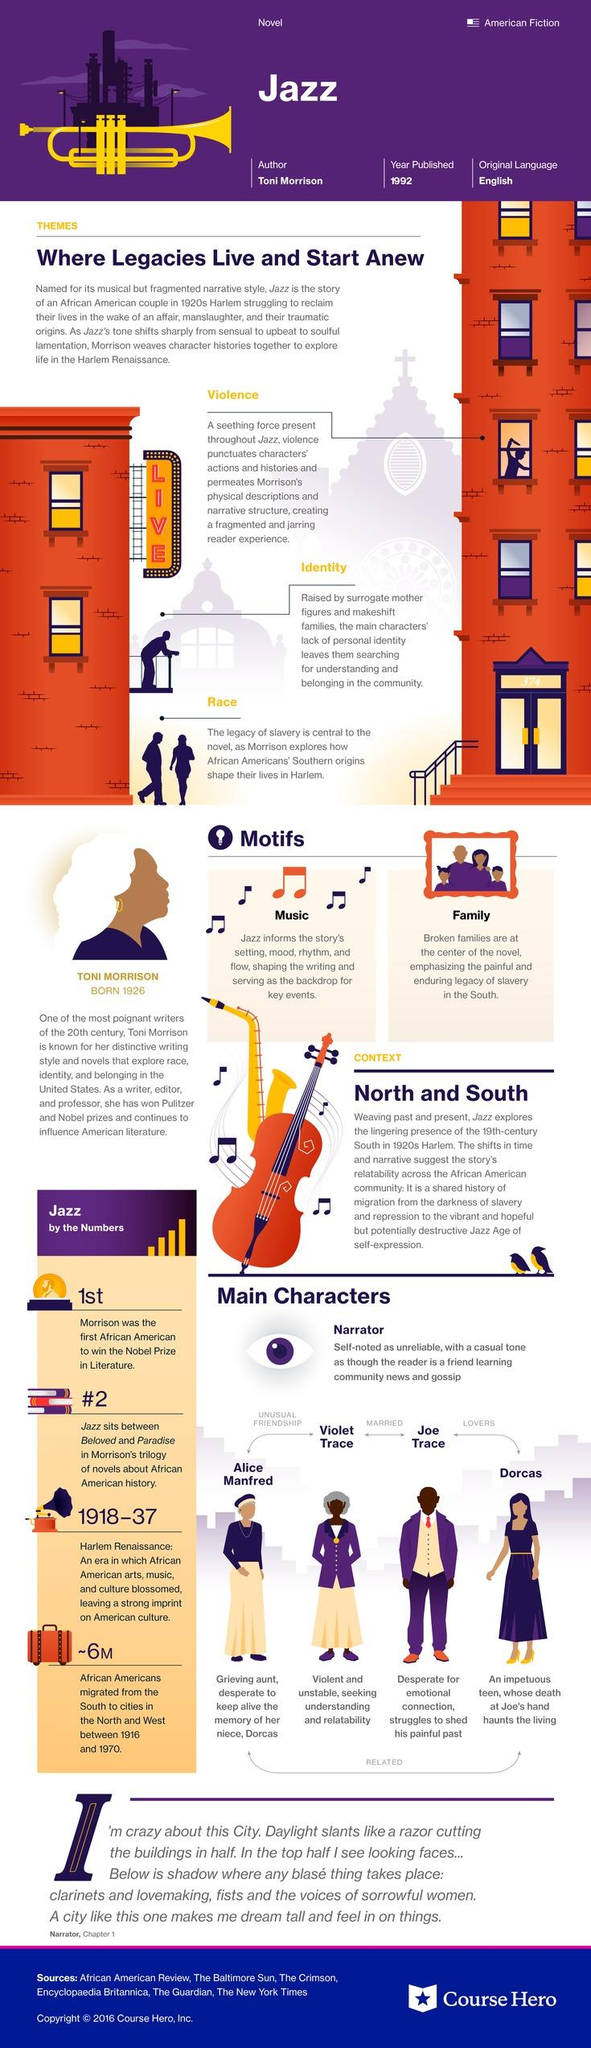Draw attention to some important aspects in this diagram. In the novel Jazz, Joe Trace is the husband of Violet Trace. In the novel "Jazz," Joe Trace is the lover of Dorcas. The novel "Jazz" explores the themes of violence, identity, and race, delving deep into the complexities of these themes and their impact on the lives of the characters. 